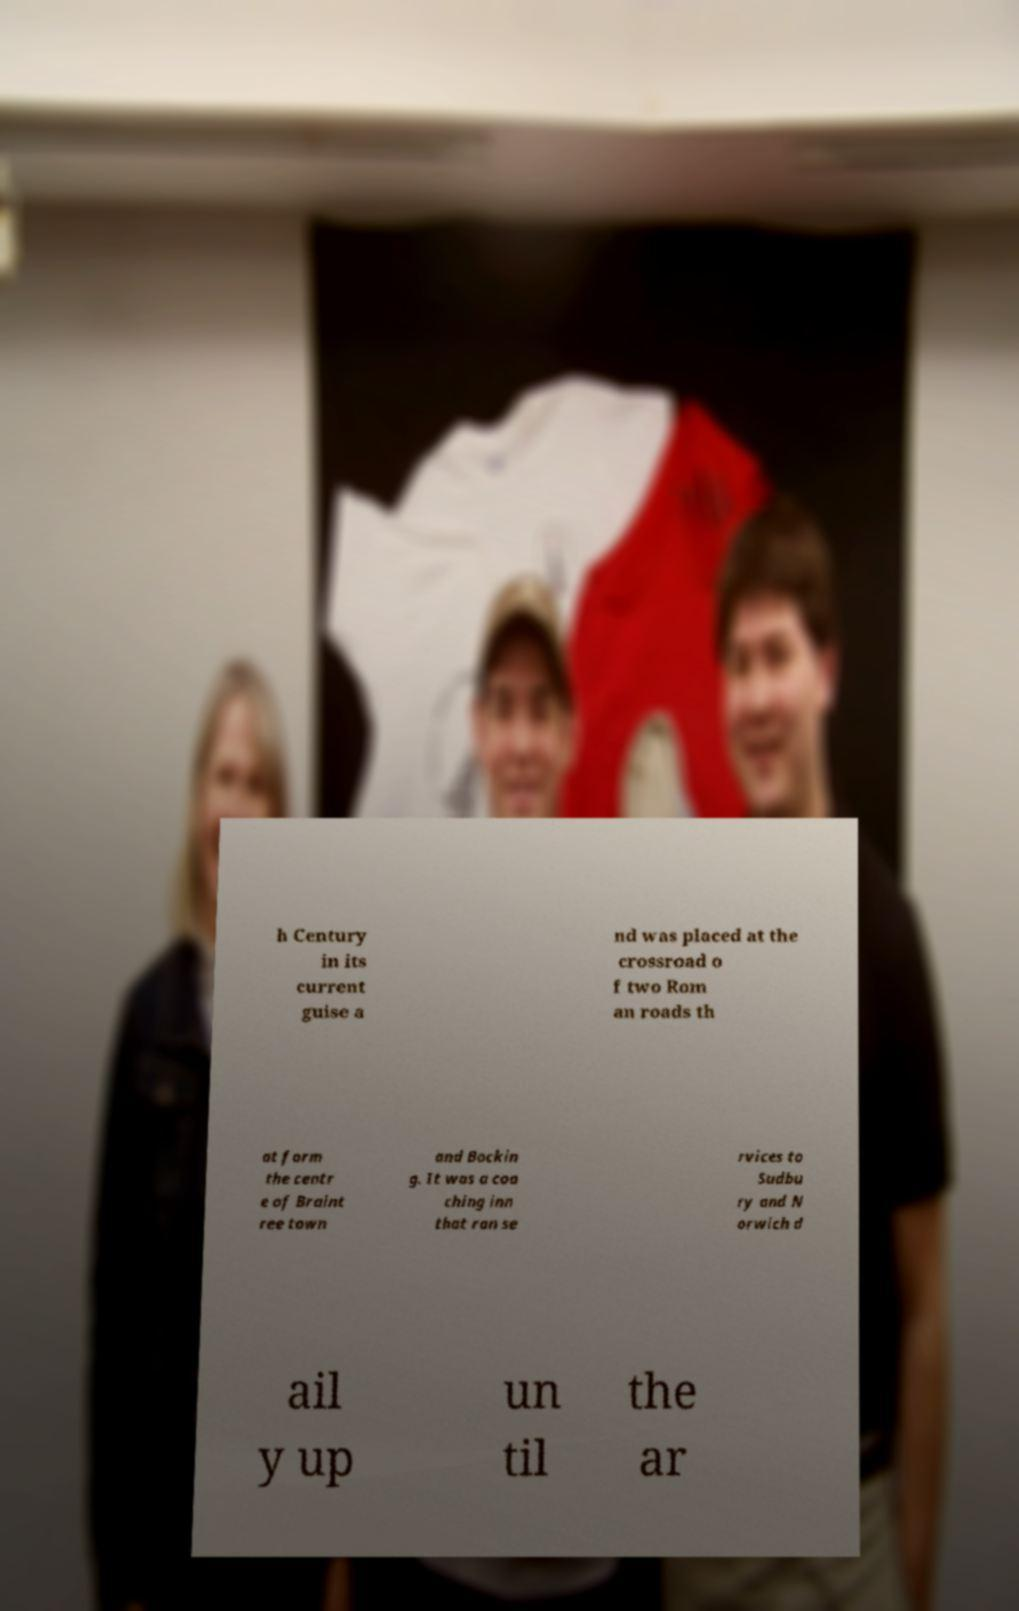What messages or text are displayed in this image? I need them in a readable, typed format. h Century in its current guise a nd was placed at the crossroad o f two Rom an roads th at form the centr e of Braint ree town and Bockin g. It was a coa ching inn that ran se rvices to Sudbu ry and N orwich d ail y up un til the ar 